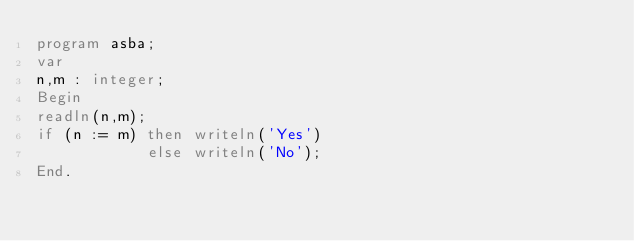Convert code to text. <code><loc_0><loc_0><loc_500><loc_500><_Pascal_>program asba;
var
n,m : integer;
Begin
readln(n,m);
if (n := m) then writeln('Yes')
			else writeln('No');
End.
</code> 